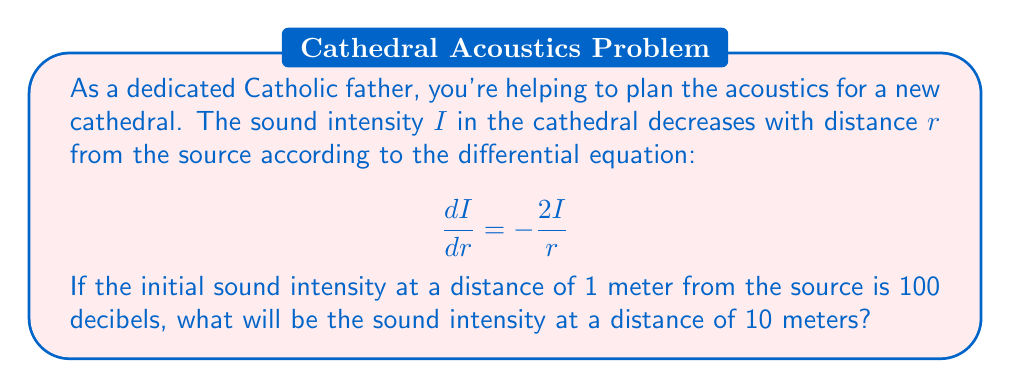Teach me how to tackle this problem. To solve this problem, we need to follow these steps:

1) First, we need to solve the differential equation. This is a separable equation, so we can rewrite it as:

   $$\frac{dI}{I} = -\frac{2}{r}dr$$

2) Integrating both sides:

   $$\int \frac{dI}{I} = -2\int \frac{1}{r}dr$$

   $$\ln|I| = -2\ln|r| + C$$

3) Using the properties of logarithms, we can rewrite this as:

   $$\ln|I| = \ln|r^{-2}| + C$$
   $$I = Kr^{-2}$$

   where $K = e^C$ is a constant we need to determine.

4) We're given that $I = 100$ when $r = 1$. Let's use this to find $K$:

   $$100 = K(1)^{-2}$$
   $$K = 100$$

5) So our solution is:

   $$I = 100r^{-2}$$

6) Now we can find $I$ when $r = 10$:

   $$I = 100(10)^{-2} = 100(0.01) = 1$$

Therefore, at a distance of 10 meters, the sound intensity will be 1 decibel.
Answer: 1 decibel 